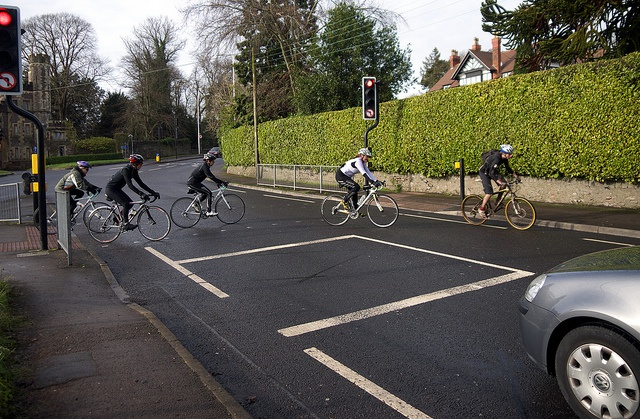Describe the objects in this image and their specific colors. I can see car in lavender, black, darkgray, gray, and lightgray tones, bicycle in lavender, gray, black, and darkgray tones, bicycle in lavender, gray, black, and darkgray tones, bicycle in lavender, black, and gray tones, and bicycle in lavender, gray, black, and darkgray tones in this image. 